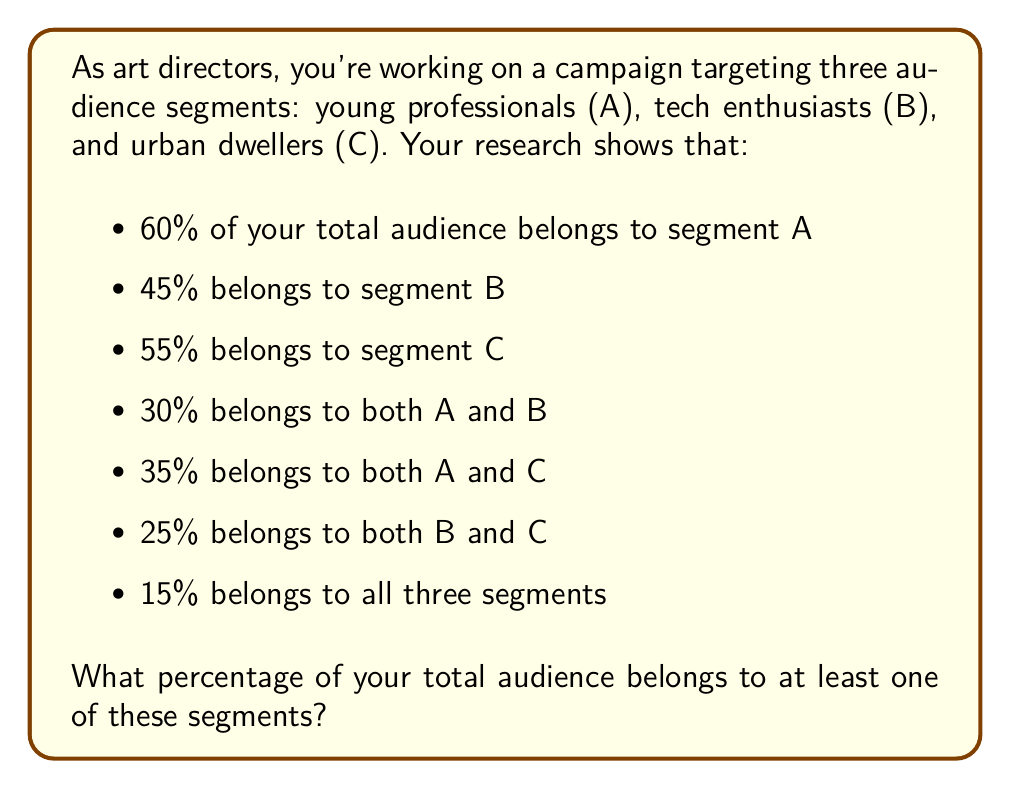Provide a solution to this math problem. To solve this problem, we'll use the principle of inclusion-exclusion for three sets. Let's define our universe as the total audience, and our sets as:

A: young professionals
B: tech enthusiasts
C: urban dwellers

The principle of inclusion-exclusion for three sets states:

$$|A \cup B \cup C| = |A| + |B| + |C| - |A \cap B| - |A \cap C| - |B \cap C| + |A \cap B \cap C|$$

Where $|X|$ represents the size of set X as a percentage of the total audience.

Given:
$|A| = 60\%$
$|B| = 45\%$
$|C| = 55\%$
$|A \cap B| = 30\%$
$|A \cap C| = 35\%$
$|B \cap C| = 25\%$
$|A \cap B \cap C| = 15\%$

Substituting these values into our equation:

$$|A \cup B \cup C| = 60\% + 45\% + 55\% - 30\% - 35\% - 25\% + 15\%$$

$$|A \cup B \cup C| = 160\% - 90\% + 15\% = 85\%$$

Therefore, 85% of the total audience belongs to at least one of these segments.
Answer: 85% 